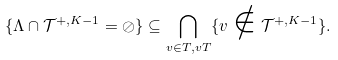<formula> <loc_0><loc_0><loc_500><loc_500>\{ \Lambda \cap \mathcal { T } ^ { + , K - 1 } = \oslash \} \subseteq \bigcap _ { v \in T , v T } \{ v \notin \mathcal { T } ^ { + , K - 1 } \} .</formula> 